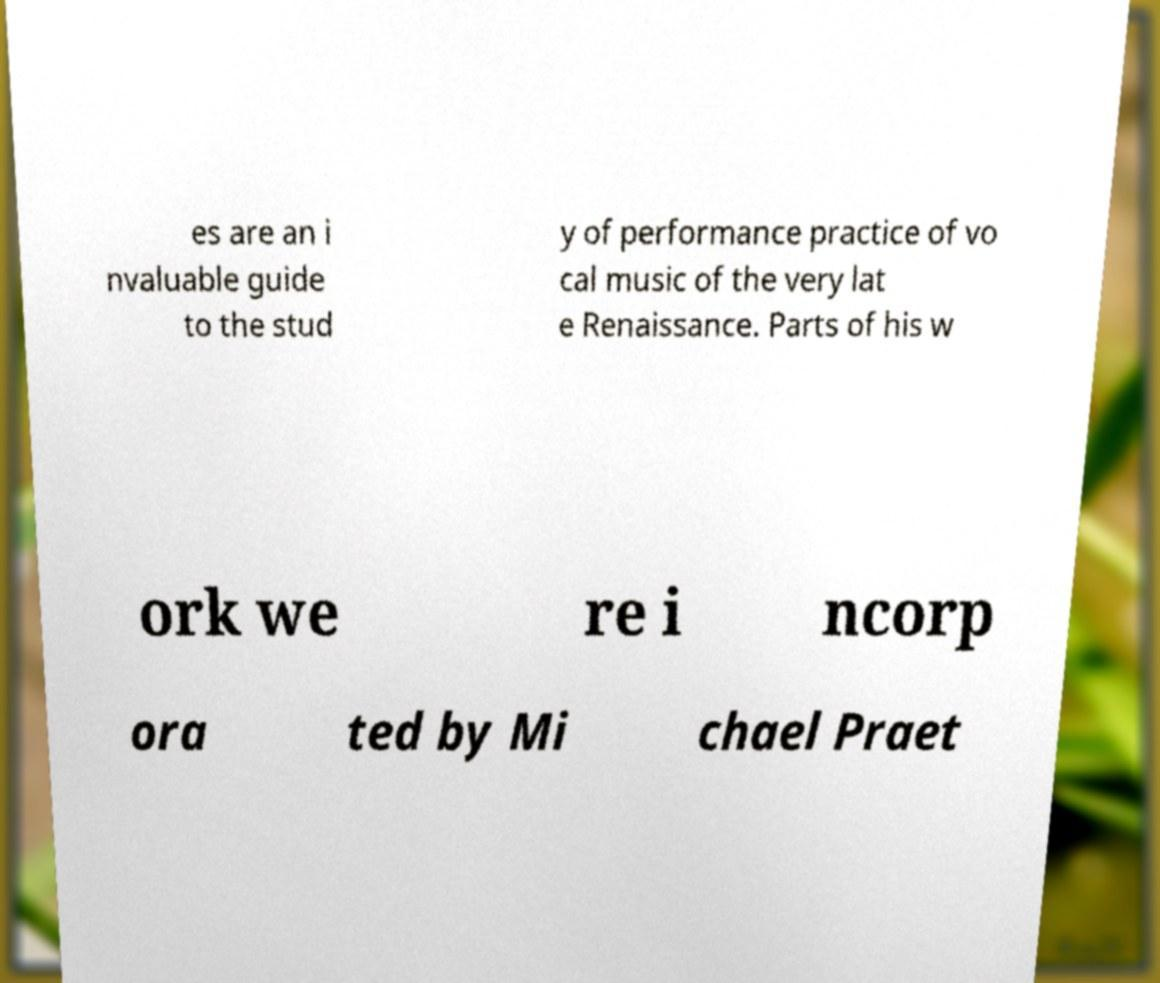Could you extract and type out the text from this image? es are an i nvaluable guide to the stud y of performance practice of vo cal music of the very lat e Renaissance. Parts of his w ork we re i ncorp ora ted by Mi chael Praet 